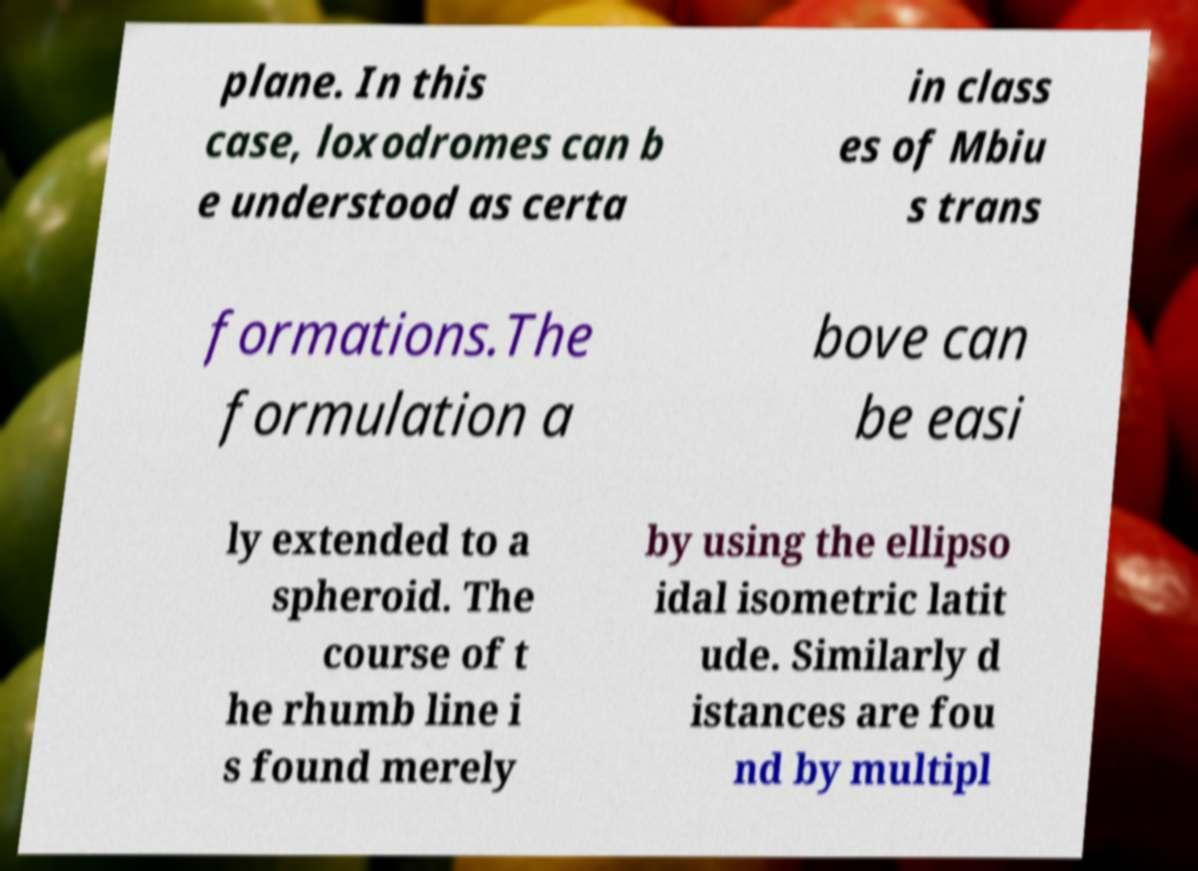For documentation purposes, I need the text within this image transcribed. Could you provide that? plane. In this case, loxodromes can b e understood as certa in class es of Mbiu s trans formations.The formulation a bove can be easi ly extended to a spheroid. The course of t he rhumb line i s found merely by using the ellipso idal isometric latit ude. Similarly d istances are fou nd by multipl 